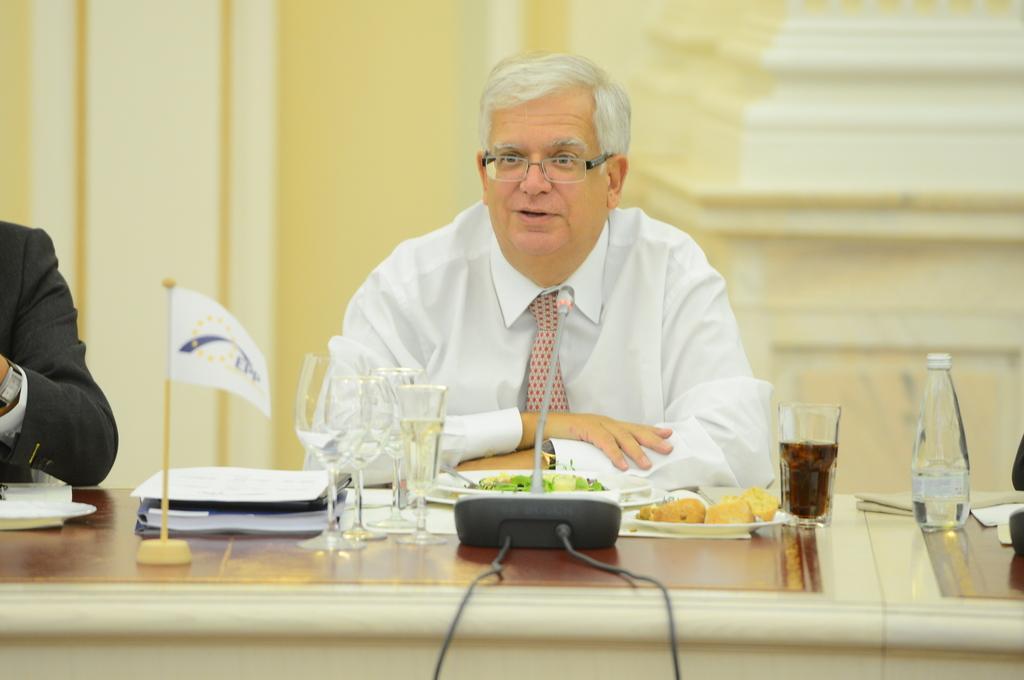Could you give a brief overview of what you see in this image? In this picture a white shirt guy is sitting on the table on top of which food items , and mic , flag is placed. The background is a yellow wall. 